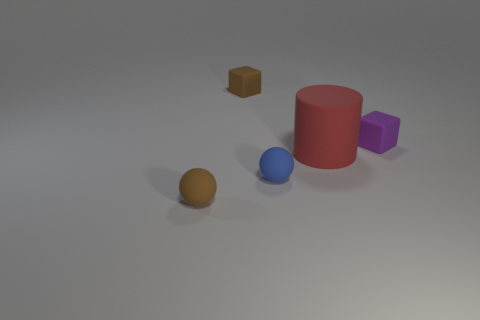There is a block that is right of the large red cylinder; what is it made of? The block to the right of the large red cylinder appears to be made of a matte material with a solid and somewhat reflective surface, suggesting it could be a type of plastic or a visually similar synthetic material. 